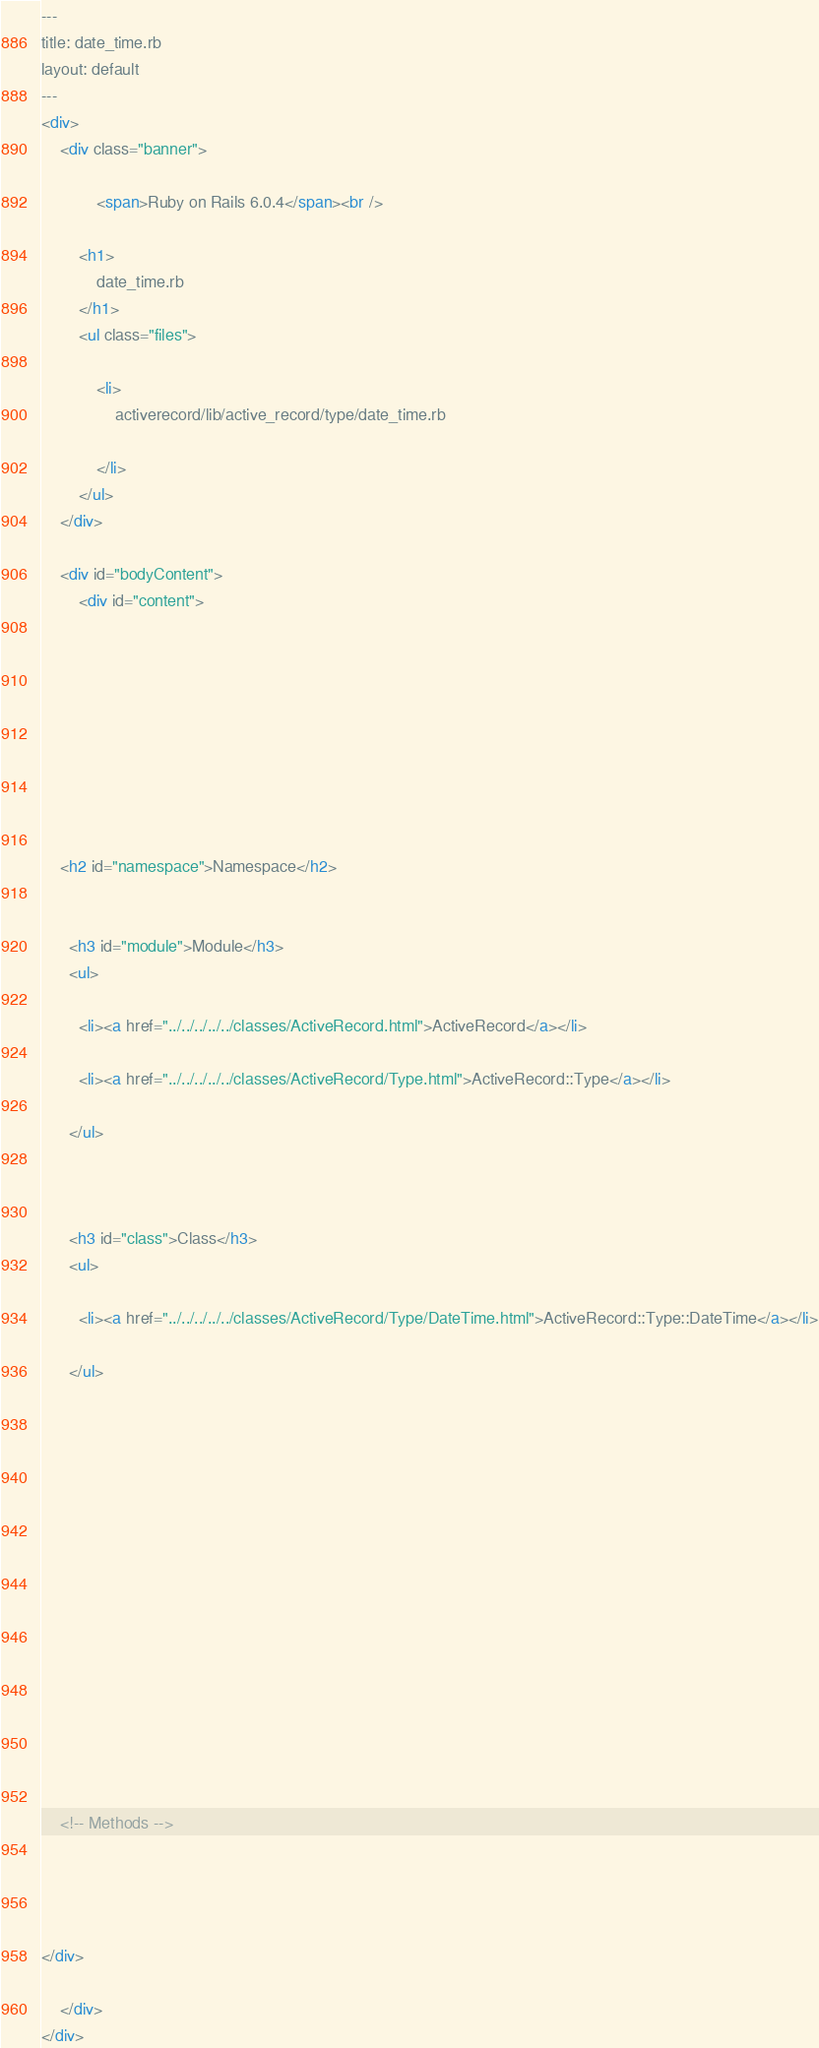<code> <loc_0><loc_0><loc_500><loc_500><_HTML_>---
title: date_time.rb
layout: default
---
<div>
    <div class="banner">
        
            <span>Ruby on Rails 6.0.4</span><br />
        
        <h1>
            date_time.rb
        </h1>
        <ul class="files">
            
            <li>
                activerecord/lib/active_record/type/date_time.rb
                
            </li>
        </ul>
    </div>

    <div id="bodyContent">
        <div id="content">
  

  

  
  


  
    <h2 id="namespace">Namespace</h2>

    
      <h3 id="module">Module</h3>
      <ul>
      
        <li><a href="../../../../../classes/ActiveRecord.html">ActiveRecord</a></li>
      
        <li><a href="../../../../../classes/ActiveRecord/Type.html">ActiveRecord::Type</a></li>
      
      </ul>
    

    
      <h3 id="class">Class</h3>
      <ul>
      
        <li><a href="../../../../../classes/ActiveRecord/Type/DateTime.html">ActiveRecord::Type::DateTime</a></li>
      
      </ul>
    
  

  

  

  
    

    

    

    

    <!-- Methods -->
    
    
    
  
</div>

    </div>
</div>
</code> 